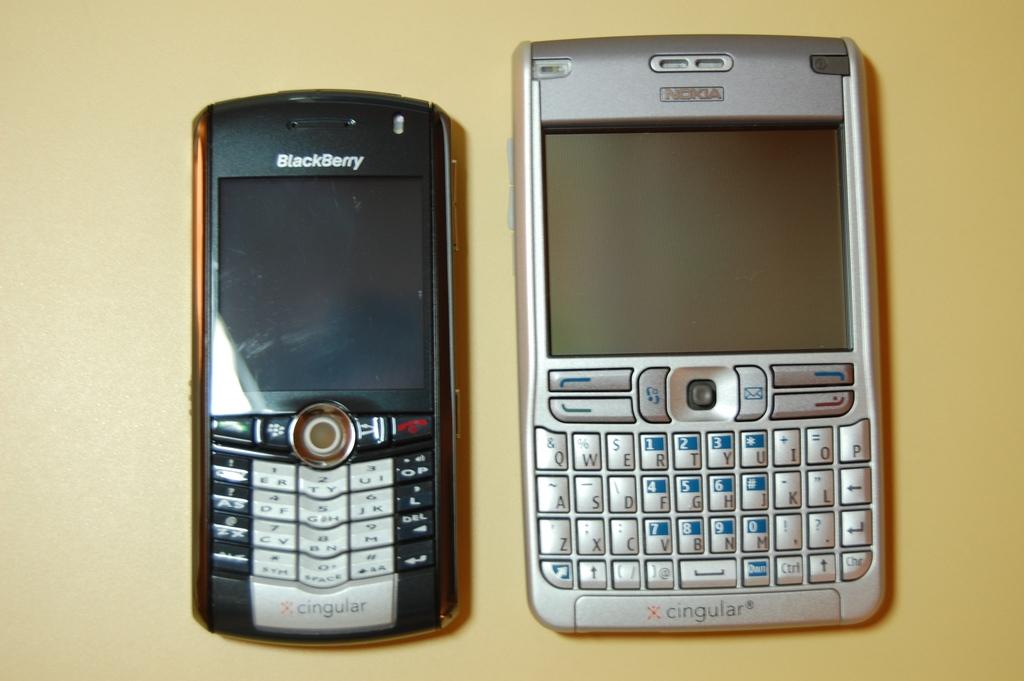What brand is the cell phone on the right?
Keep it short and to the point. Nokia. What brand is the cell phone on the left?
Give a very brief answer. Blackberry. 